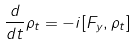Convert formula to latex. <formula><loc_0><loc_0><loc_500><loc_500>\frac { d } { d t } \rho _ { t } = - i [ F _ { y } , \rho _ { t } ]</formula> 